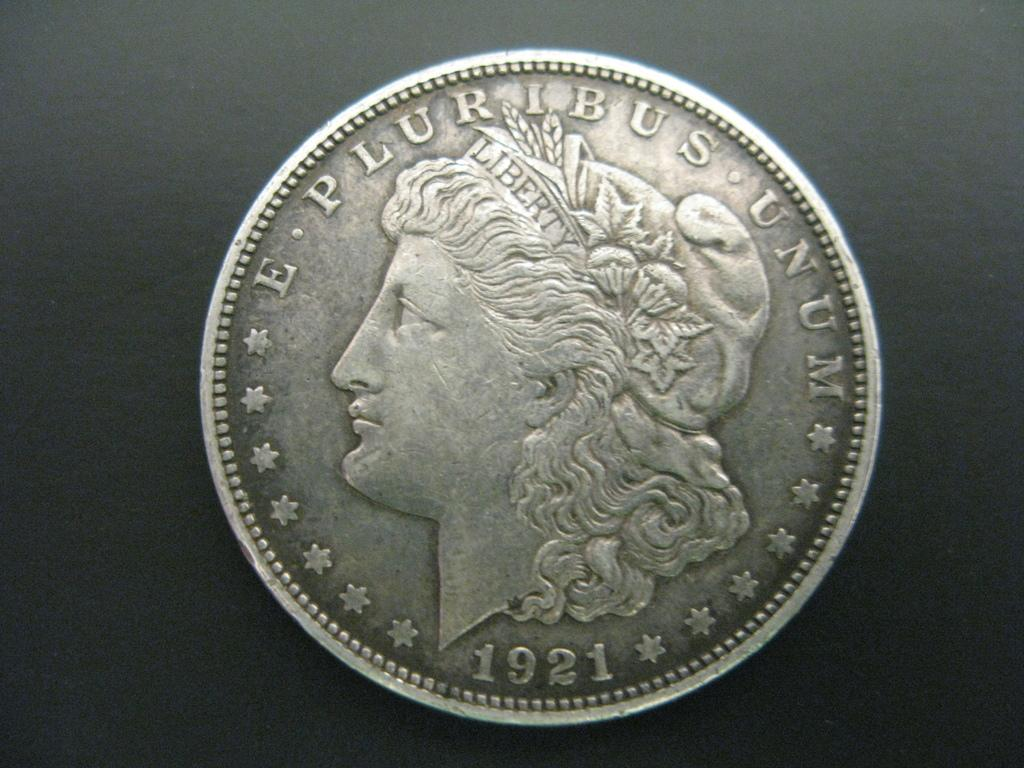<image>
Describe the image concisely. A coin with a woman that is dated 1921. 